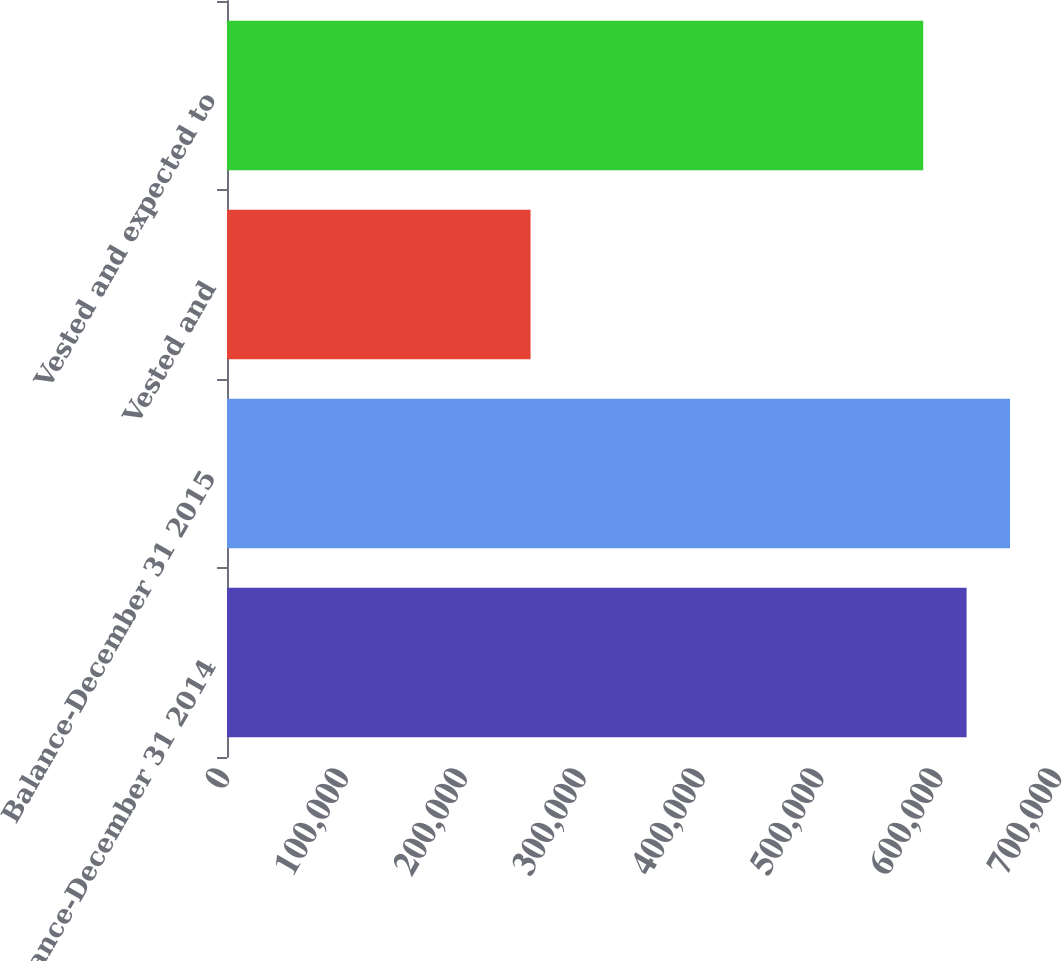Convert chart. <chart><loc_0><loc_0><loc_500><loc_500><bar_chart><fcel>Balance-December 31 2014<fcel>Balance-December 31 2015<fcel>Vested and<fcel>Vested and expected to<nl><fcel>622268<fcel>658809<fcel>255392<fcel>585727<nl></chart> 